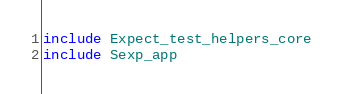<code> <loc_0><loc_0><loc_500><loc_500><_OCaml_>include Expect_test_helpers_core
include Sexp_app
</code> 